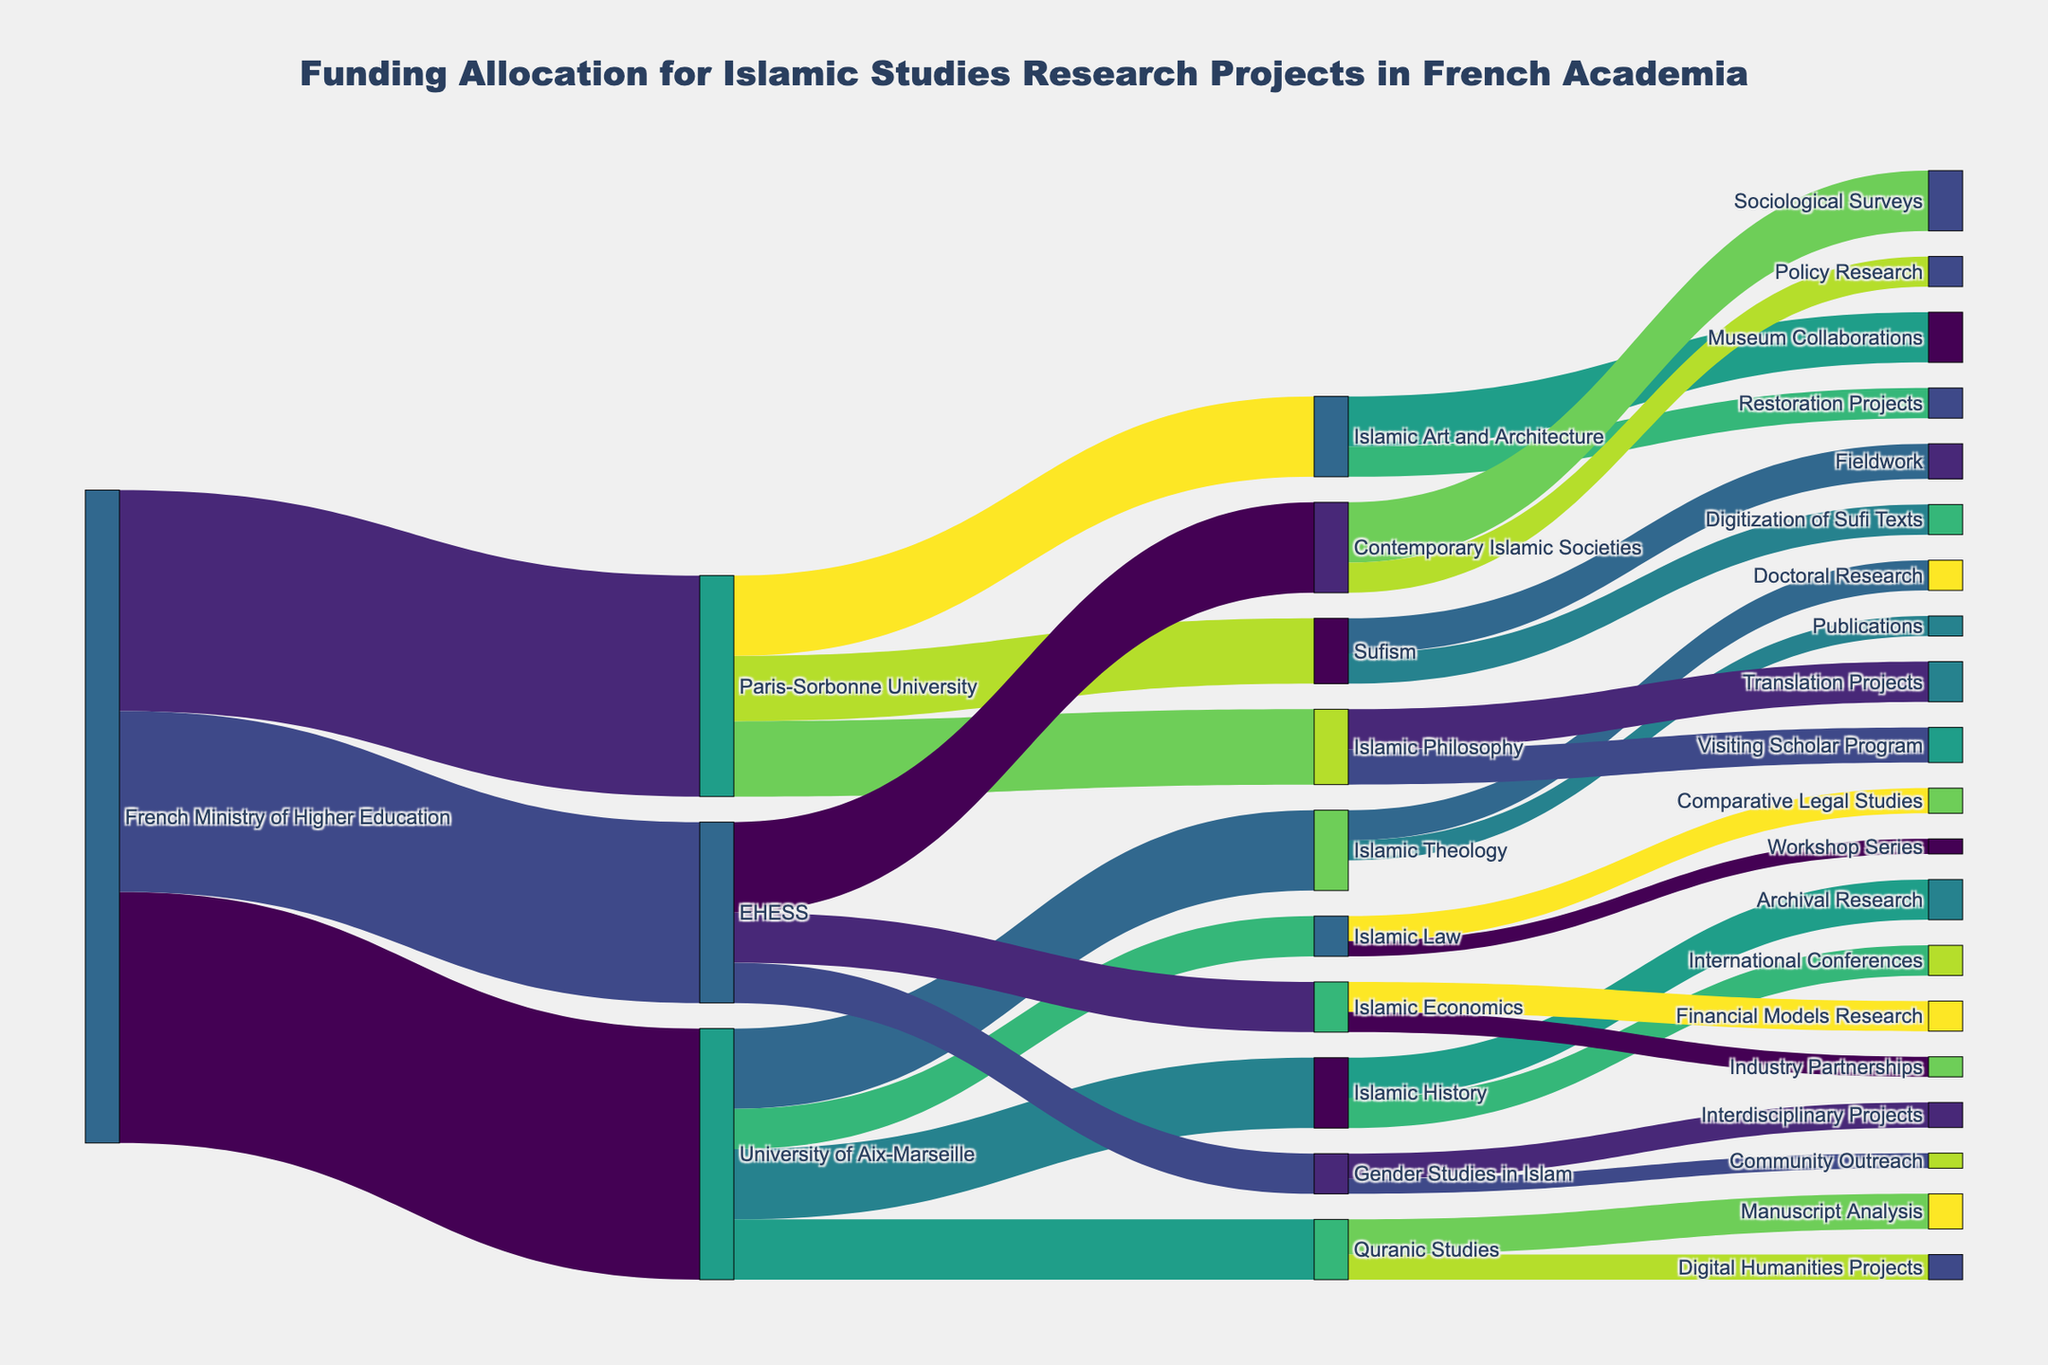What's the total funding allocated by the French Ministry of Higher Education? To find the total funding allocated by the French Ministry of Higher Education, sum all the values originating from this source: 2,500,000 (University of Aix-Marseille) + 2,200,000 (Paris-Sorbonne University) + 1,800,000 (EHESS) = 6,500,000
Answer: 6,500,000 Which university received the highest funding? Compare the values each university received from the French Ministry of Higher Education: University of Aix-Marseille (2,500,000), Paris-Sorbonne University (2,200,000), EHESS (1,800,000). The University of Aix-Marseille received the highest funding.
Answer: University of Aix-Marseille How much funding was allocated to Islamic Theology within University of Aix-Marseille? The figure shows a flow from the University of Aix-Marseille to Islamic Theology amounting to 800,000.
Answer: 800,000 What's the combined funding amount for Paris-Sorbonne University's Islamic Philosophy and Islamic Art and Architecture? Summing the funding amounts: Islamic Philosophy (750,000) + Islamic Art and Architecture (800,000) = 1,550,000
Answer: 1,550,000 Compare the funding for Quranic Studies and Islamic Law at the University of Aix-Marseille. Which received more, and by how much? Quranic Studies received 600,000 while Islamic Law received 400,000. The difference is 600,000 - 400,000 = 200,000. Quranic Studies received 200,000 more.
Answer: Quranic Studies by 200,000 What proportion of EHESS's funding was allocated to Contemporary Islamic Societies? EHESS received 1,800,000 in total. The funding for Contemporary Islamic Societies is 900,000. The proportion is 900,000 / 1,800,000 = 0.5 or 50%.
Answer: 50% What's the funding allocation for Digital Humanities Projects under Quranic Studies? The figure shows a flow of 250,000 from Quranic Studies to Digital Humanities Projects.
Answer: 250,000 Which specific project under Gender Studies in Islam received the least funding? Gender Studies in Islam has two projects: Interdisciplinary Projects (250,000) and Community Outreach (150,000). Community Outreach received the least funding.
Answer: Community Outreach Calculate the funding difference between Sociological Surveys and Policy Research under Contemporary Islamic Societies at EHESS. Sociological Surveys received 600,000 while Policy Research received 300,000. The difference is 600,000 - 300,000 = 300,000.
Answer: 300,000 Identify the project with the highest funding under Paris-Sorbonne University and state its amount. The projects and their funds are Islamic Philosophy (750,000), Sufism (650,000), Islamic Art and Architecture (800,000). Islamic Art and Architecture received the highest funding with 800,000.
Answer: Islamic Art and Architecture, 800,000 